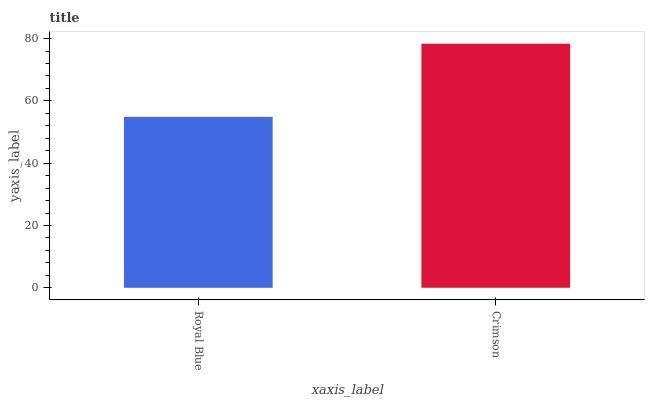Is Royal Blue the minimum?
Answer yes or no. Yes. Is Crimson the maximum?
Answer yes or no. Yes. Is Crimson the minimum?
Answer yes or no. No. Is Crimson greater than Royal Blue?
Answer yes or no. Yes. Is Royal Blue less than Crimson?
Answer yes or no. Yes. Is Royal Blue greater than Crimson?
Answer yes or no. No. Is Crimson less than Royal Blue?
Answer yes or no. No. Is Crimson the high median?
Answer yes or no. Yes. Is Royal Blue the low median?
Answer yes or no. Yes. Is Royal Blue the high median?
Answer yes or no. No. Is Crimson the low median?
Answer yes or no. No. 